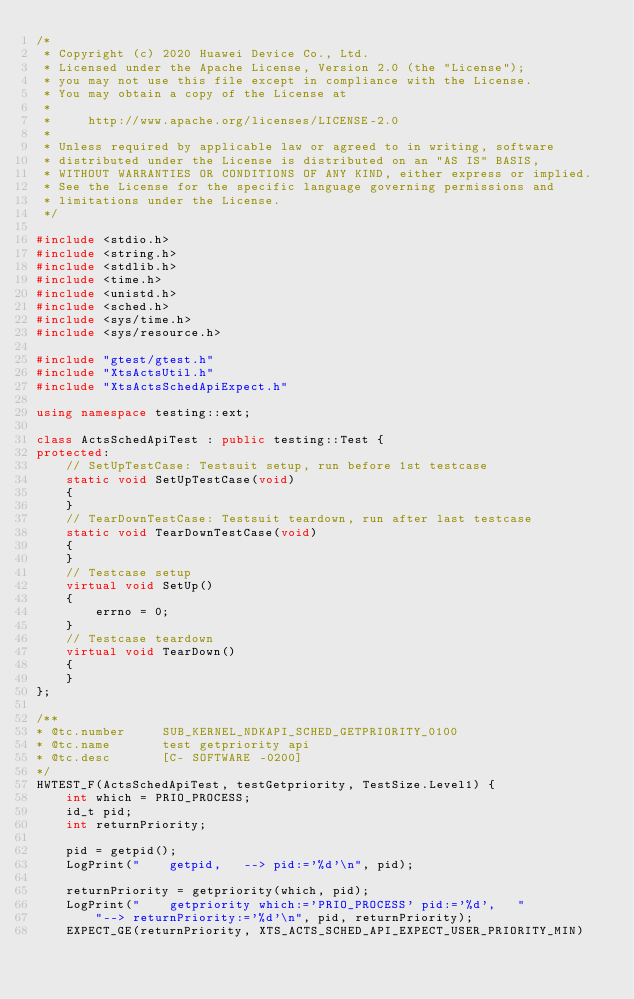<code> <loc_0><loc_0><loc_500><loc_500><_C++_>/*
 * Copyright (c) 2020 Huawei Device Co., Ltd.
 * Licensed under the Apache License, Version 2.0 (the "License");
 * you may not use this file except in compliance with the License.
 * You may obtain a copy of the License at
 *
 *     http://www.apache.org/licenses/LICENSE-2.0
 *
 * Unless required by applicable law or agreed to in writing, software
 * distributed under the License is distributed on an "AS IS" BASIS,
 * WITHOUT WARRANTIES OR CONDITIONS OF ANY KIND, either express or implied.
 * See the License for the specific language governing permissions and
 * limitations under the License.
 */

#include <stdio.h>
#include <string.h>
#include <stdlib.h>
#include <time.h>
#include <unistd.h>
#include <sched.h>
#include <sys/time.h>
#include <sys/resource.h>

#include "gtest/gtest.h"
#include "XtsActsUtil.h"
#include "XtsActsSchedApiExpect.h"

using namespace testing::ext;

class ActsSchedApiTest : public testing::Test {
protected:
    // SetUpTestCase: Testsuit setup, run before 1st testcase
    static void SetUpTestCase(void)
    {
    }
    // TearDownTestCase: Testsuit teardown, run after last testcase
    static void TearDownTestCase(void)
    {
    }
    // Testcase setup
    virtual void SetUp()
    {
        errno = 0;
    }
    // Testcase teardown
    virtual void TearDown()
    {
    }
};

/**
* @tc.number     SUB_KERNEL_NDKAPI_SCHED_GETPRIORITY_0100
* @tc.name       test getpriority api
* @tc.desc       [C- SOFTWARE -0200]
*/
HWTEST_F(ActsSchedApiTest, testGetpriority, TestSize.Level1) {
    int which = PRIO_PROCESS;
    id_t pid;
    int returnPriority;

    pid = getpid();
    LogPrint("    getpid,   --> pid:='%d'\n", pid);

    returnPriority = getpriority(which, pid);
    LogPrint("    getpriority which:='PRIO_PROCESS' pid:='%d',   "
        "--> returnPriority:='%d'\n", pid, returnPriority);
    EXPECT_GE(returnPriority, XTS_ACTS_SCHED_API_EXPECT_USER_PRIORITY_MIN)</code> 